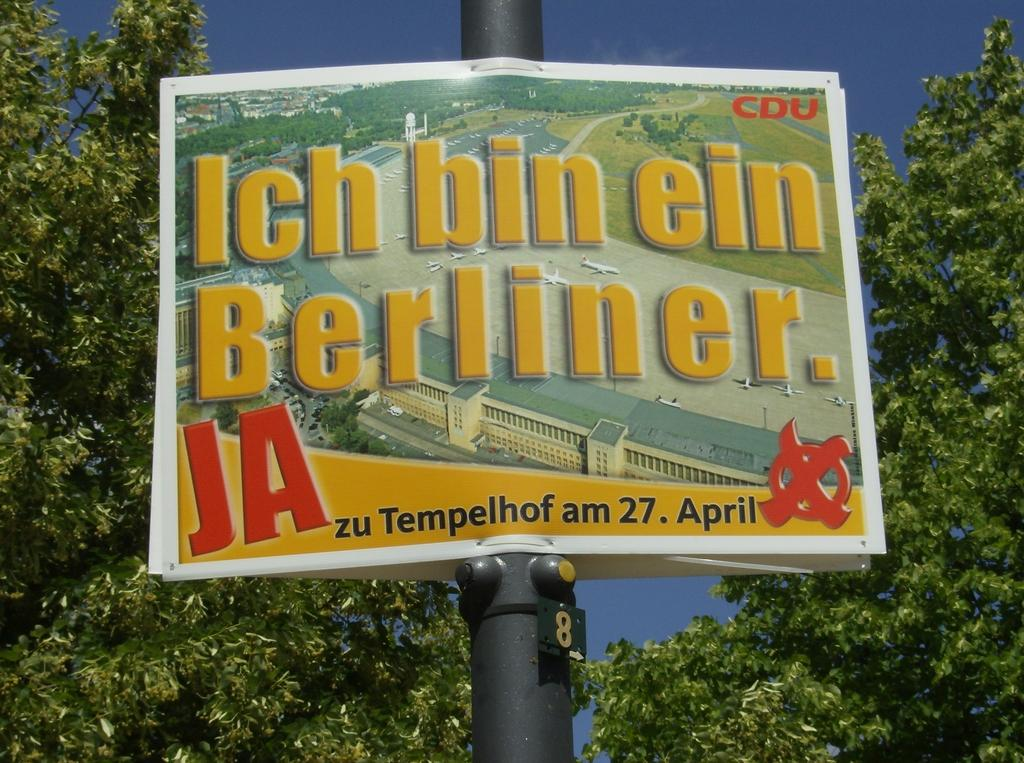What is the main object in the image? There is a pole in the image. What is attached to the pole? There are posters on the pole. What can be seen in the background of the image? There are trees in the background of the image. What is visible at the top of the image? The sky is visible at the top of the image. What type of jam is being spread on the wire in the image? There is no jam or wire present in the image. 